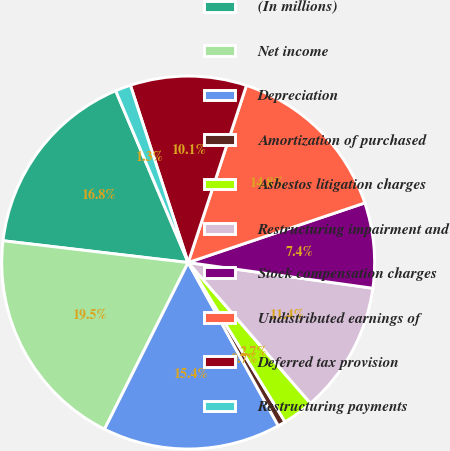Convert chart. <chart><loc_0><loc_0><loc_500><loc_500><pie_chart><fcel>(In millions)<fcel>Net income<fcel>Depreciation<fcel>Amortization of purchased<fcel>Asbestos litigation charges<fcel>Restructuring impairment and<fcel>Stock compensation charges<fcel>Undistributed earnings of<fcel>Deferred tax provision<fcel>Restructuring payments<nl><fcel>16.78%<fcel>19.46%<fcel>15.43%<fcel>0.67%<fcel>2.69%<fcel>11.41%<fcel>7.38%<fcel>14.76%<fcel>10.07%<fcel>1.34%<nl></chart> 